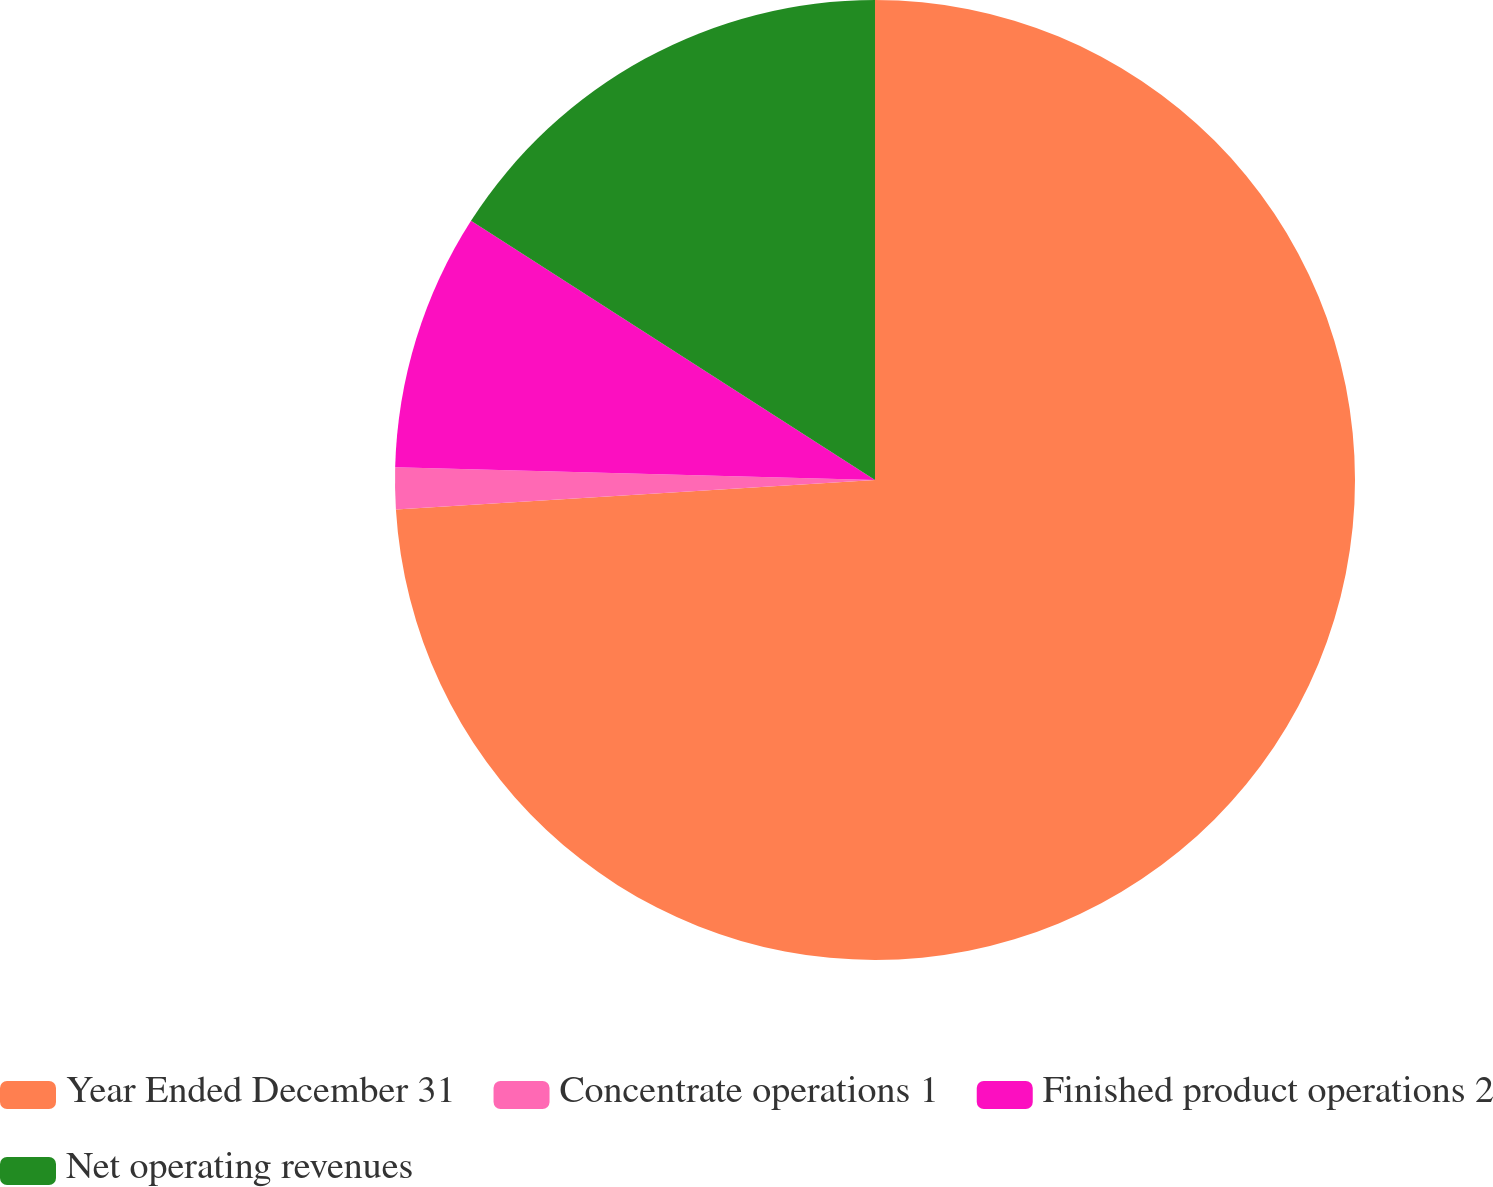Convert chart to OTSL. <chart><loc_0><loc_0><loc_500><loc_500><pie_chart><fcel>Year Ended December 31<fcel>Concentrate operations 1<fcel>Finished product operations 2<fcel>Net operating revenues<nl><fcel>74.02%<fcel>1.4%<fcel>8.66%<fcel>15.92%<nl></chart> 